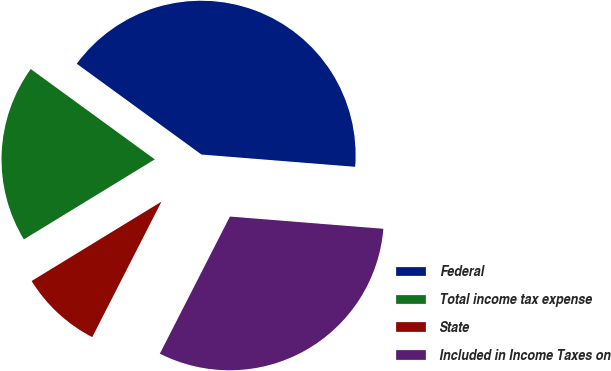Convert chart. <chart><loc_0><loc_0><loc_500><loc_500><pie_chart><fcel>Federal<fcel>Total income tax expense<fcel>State<fcel>Included in Income Taxes on<nl><fcel>41.25%<fcel>18.75%<fcel>8.75%<fcel>31.25%<nl></chart> 